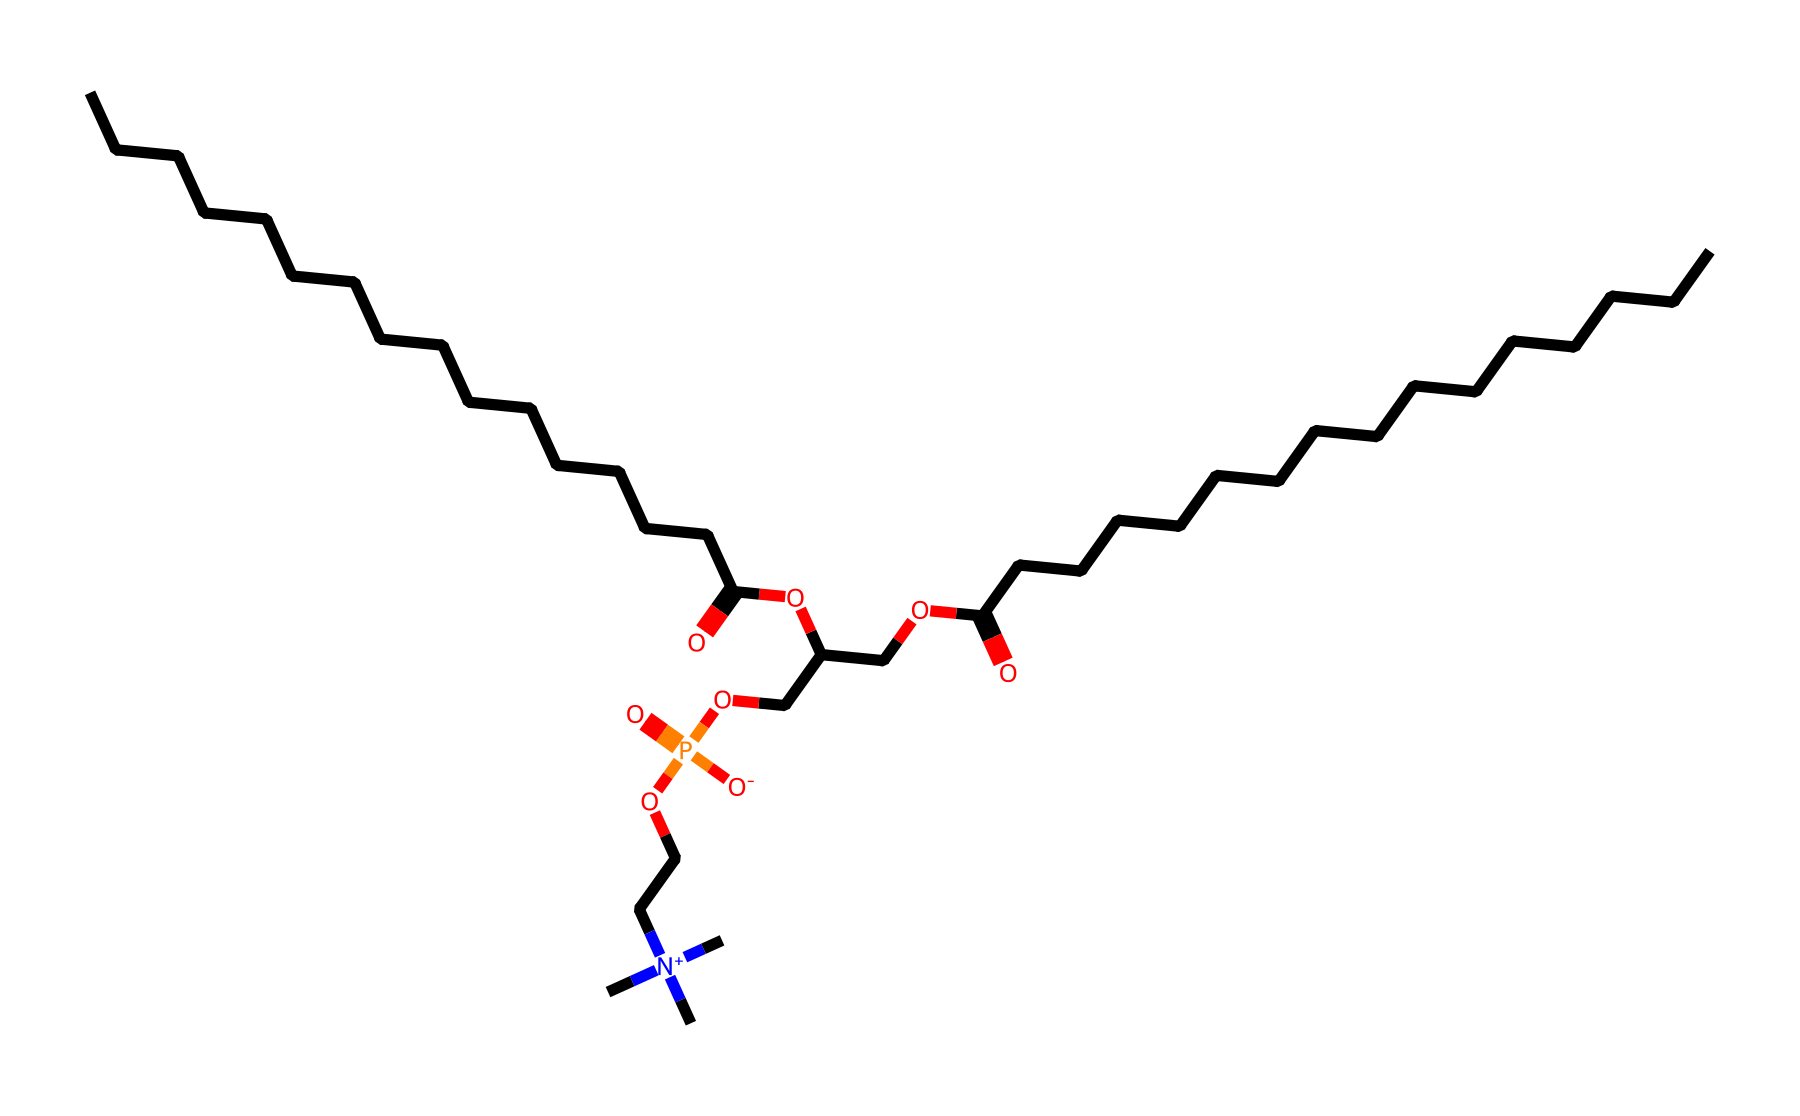What type of molecule is represented by this SMILES? The structure corresponds to a phospholipid, identifiable by the presence of both phosphorus and fatty acid chains, indicating it's a glycerophospholipid.
Answer: phospholipid How many carbon atoms are in this chemical? Counting the carbon atoms from the provided structure, there are 30 carbon atoms present in the two fatty acid tails and the glycerol backbone.
Answer: 30 What functional group is responsible for the molecule's acidity? The carboxylic acid functional group (–COOH) on the fatty acid chains contributes to the molecule's acidic characteristics.
Answer: carboxylic acid How many phosphorus atoms are there in this molecule? The SMILES contains one phosphorus atom, indicated by the phosphorus notation, which is central to the phospholipid structure.
Answer: 1 What type of bond connects the fatty acid chains to the glycerol backbone? The fatty acid chains are connected to the glycerol backbone via ester bonds, formed through the reaction of the hydroxyl group of glycerol and the carboxylic acid of the fatty acids.
Answer: ester bonds What does the presence of nitrogen in this compound suggest about its properties? The nitrogen is part of a quaternary ammonium group, which enhances the compound's solubility in biological membranes and contributes to its amphiphilic nature.
Answer: amphiphilic 